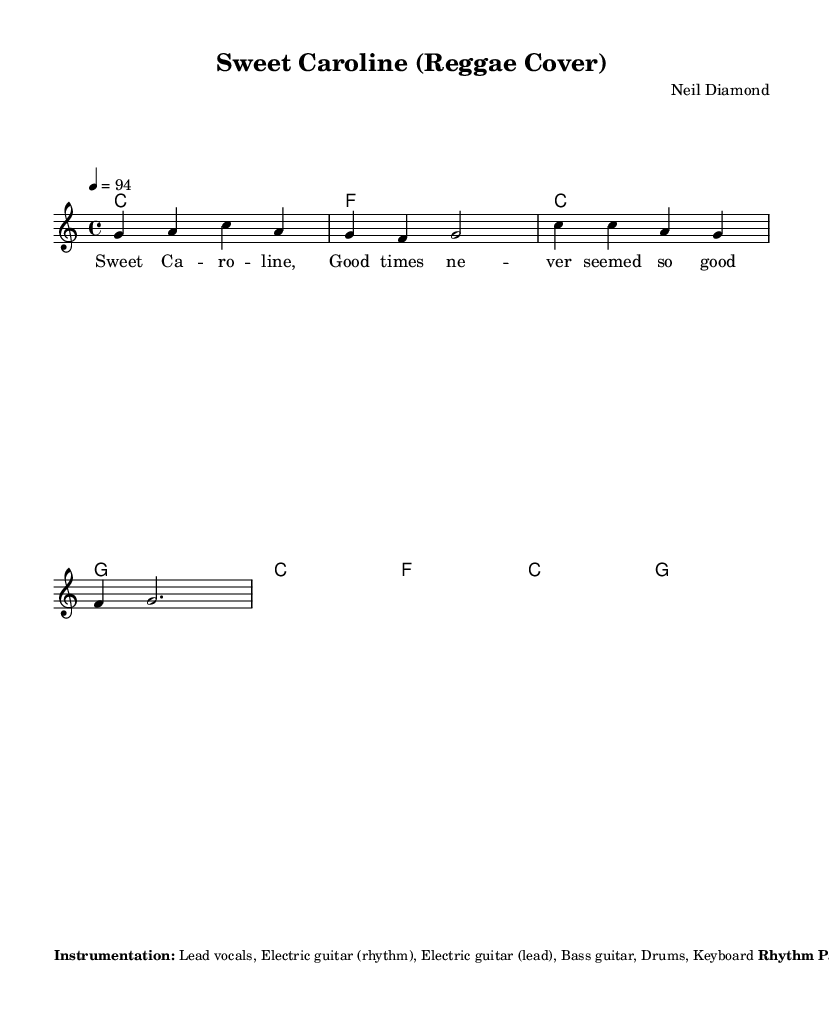What is the key signature of this music? The key signature indicated in the sheet music is C major, which contains no sharps or flats. This is shown at the beginning of the score.
Answer: C major What is the time signature of this music? The time signature indicated in the music sheet is 4/4, which means there are four beats in each measure and a quarter note gets one beat. This is noticed right after the key signature.
Answer: 4/4 What is the tempo marking for this piece? The tempo marking indicated in the music sheet is 4 = 94. This means there should be 94 beats per minute in the performance of the piece. It can be found in the tempo indication section at the beginning.
Answer: 94 How many measures are in the melody section presented? The melody consists of 4 measures as indicated by the layout of notes shown in the score. Each line contains two measures of music, and there are two lines. Therefore, the total becomes four measures.
Answer: 4 What instrumentation is used in this reggae cover? The instrumentation listed in the sheet music includes Lead vocals, Electric guitar (rhythm), Electric guitar (lead), Bass guitar, Drums, and Keyboard. This information is presented as a note below the musical notation.
Answer: Lead vocals, Electric guitar (rhythm), Electric guitar (lead), Bass guitar, Drums, Keyboard What type of rhythm pattern is noted in the score? The rhythm pattern mentioned in the markup section indicates different instruments with specific beats: Bass: X.x.X.x., Kick: X...X..., Snare: ..X...X., and Hi-hat: X.X.X.X. This structure is essential for the reggae style reflected in the piece.
Answer: Bass: X.x.X.x. X.x.X.x., Kick: X...X..., Snare: ..X...X., Hi-hat: X.X.X.X What additional notes are suggested for the performance? The additional notes suggest emphasizing the off-beat guitar chops and incorporating a reggae-style organ bubble, along with occasional ska-influenced horn stabs during instrumental breaks. This information influences the reggae feel of the piece.
Answer: Emphasize the off-beat guitar chops and incorporate a reggae-style organ bubble 